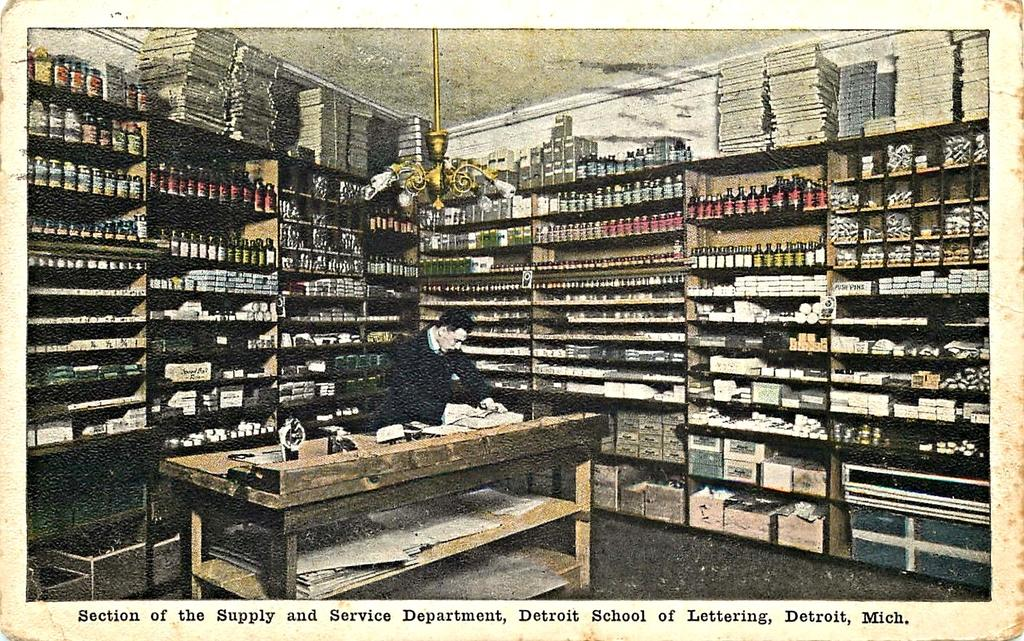<image>
Offer a succinct explanation of the picture presented. A photo of a man in a room with packed shelves at the Supply and Service Department in Michigan. 